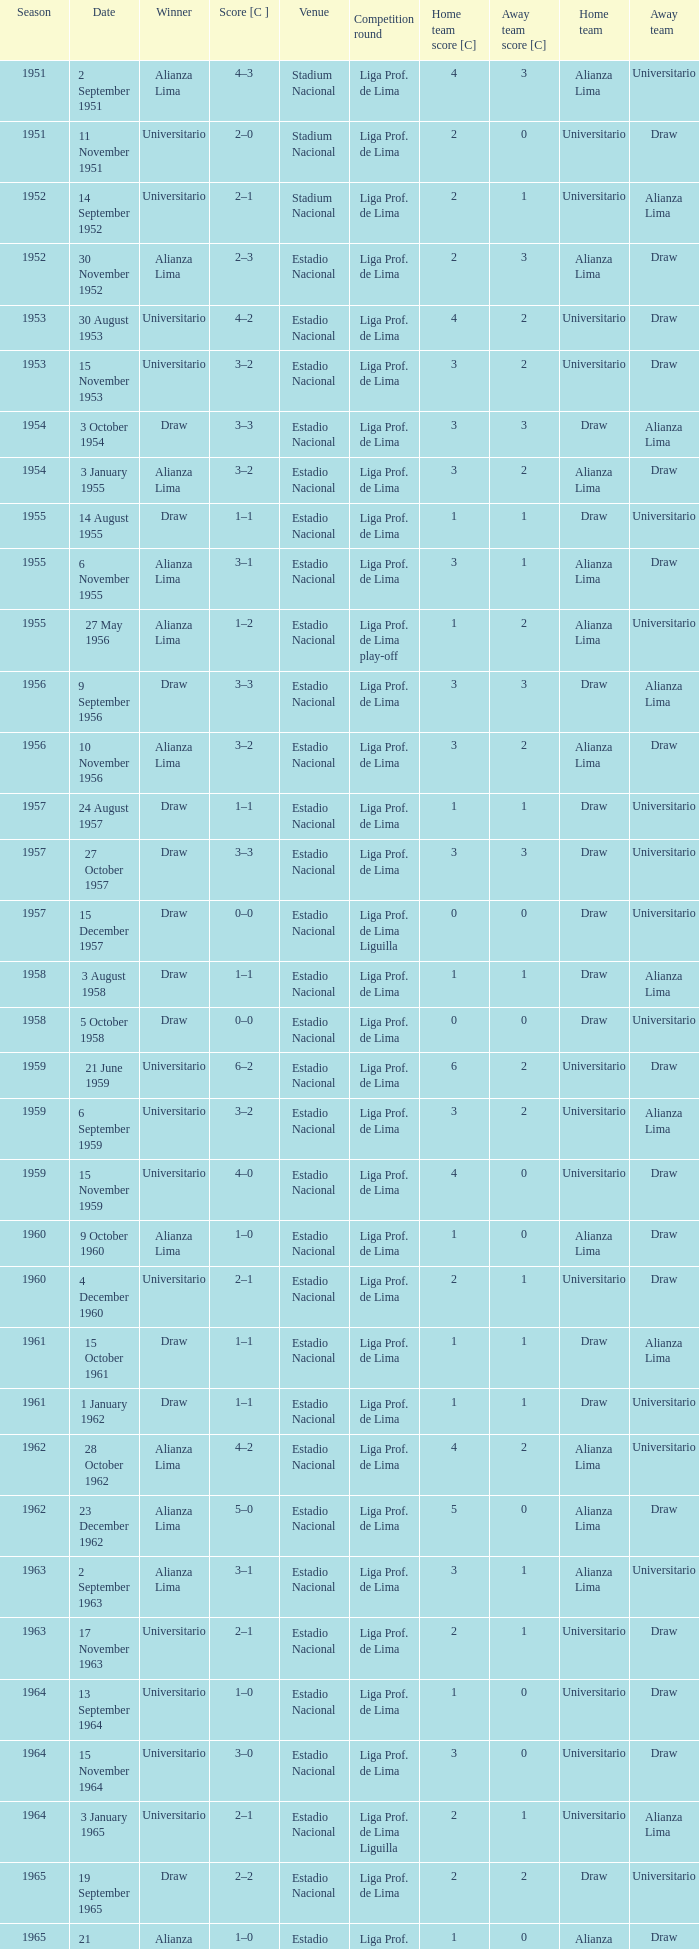Who was the winner on 15 December 1957? Draw. 